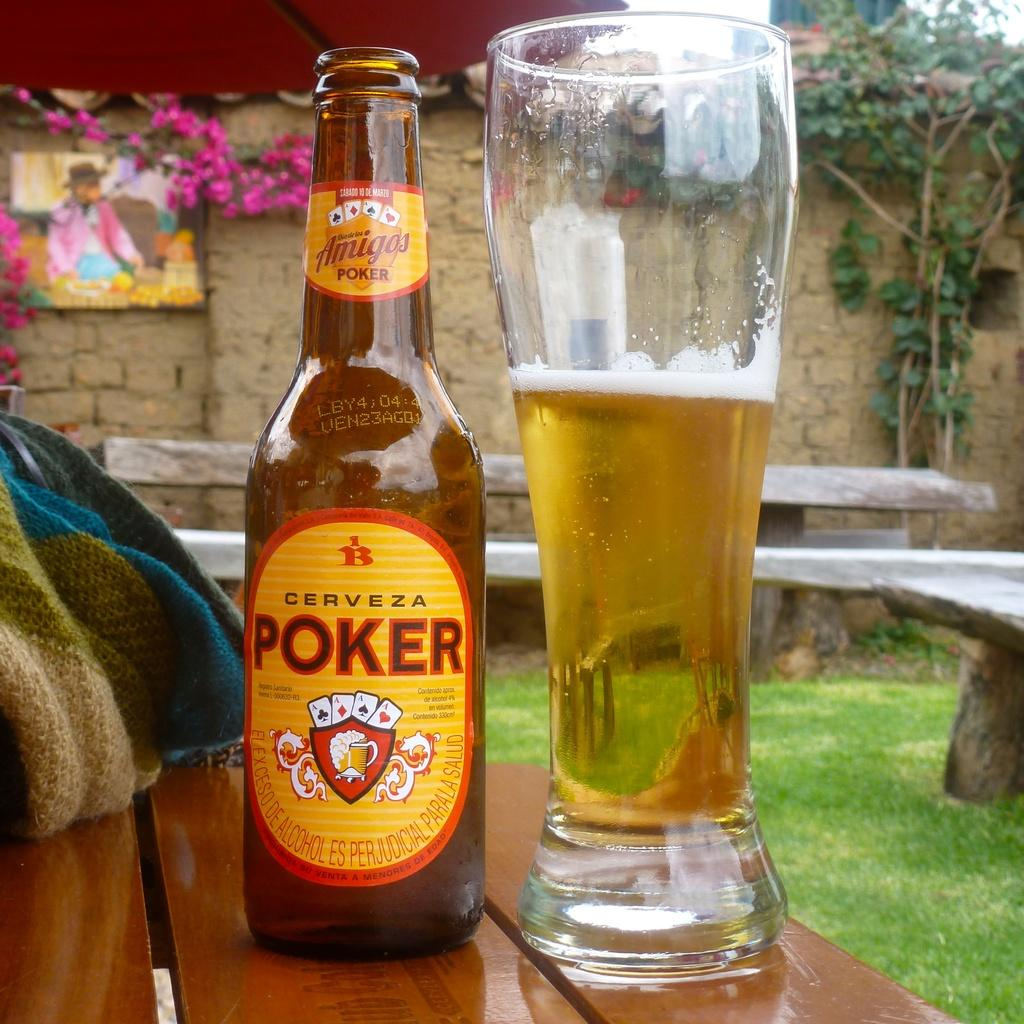What is on the table in the image? There is a beer bottle and a beer glass on the table. What can be seen on the right side of the image? There is a tree on the right side of the image, and another tree behind it. What is on the left side of the image? There is an art piece and flowers on the left side of the image. Can you tell me how many horses are depicted in the art piece on the left side of the image? There is no horse depicted in the art piece on the left side of the image. What type of grain is present in the image? There is no grain present in the image. 